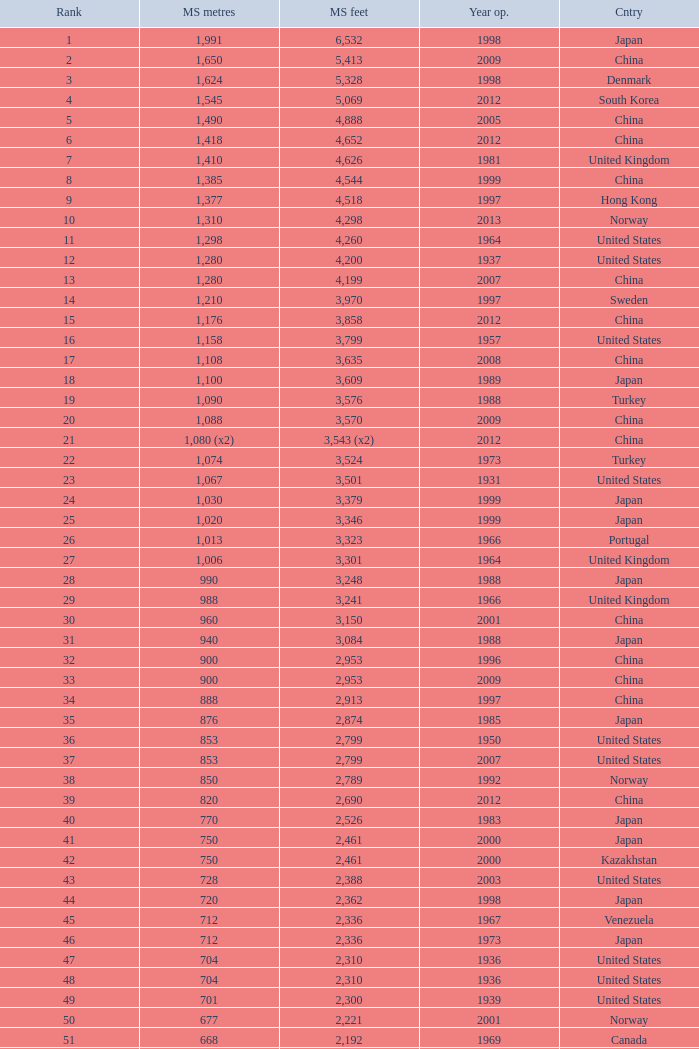What is the primary span in feet for a bridge built in or after 2009, with a ranking below 94 and a main span of 1,310 meters? 4298.0. 